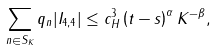<formula> <loc_0><loc_0><loc_500><loc_500>\sum _ { n \in S _ { K } } q _ { n } | I _ { 4 , 4 } | \leq c _ { H } ^ { 3 } \left ( t - s \right ) ^ { \alpha } K ^ { - \beta } ,</formula> 